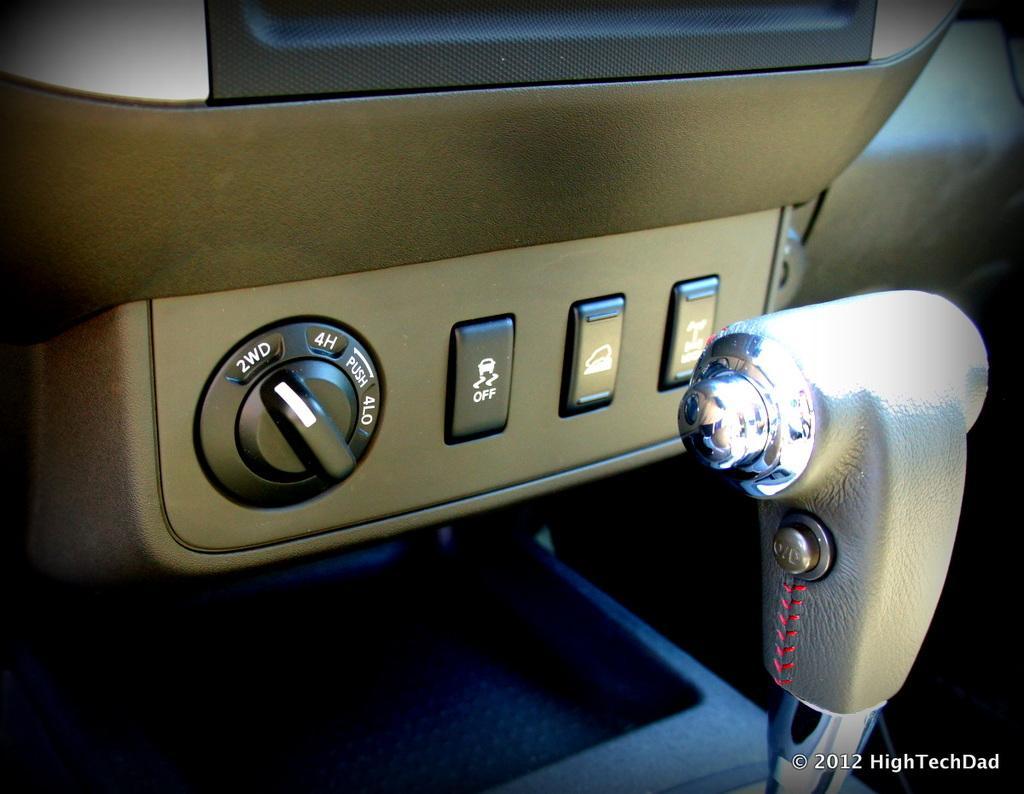In one or two sentences, can you explain what this image depicts? This is the inside picture of the car. In this image we can see a gear rod. There are switches. There is some text on the right side of the image. 